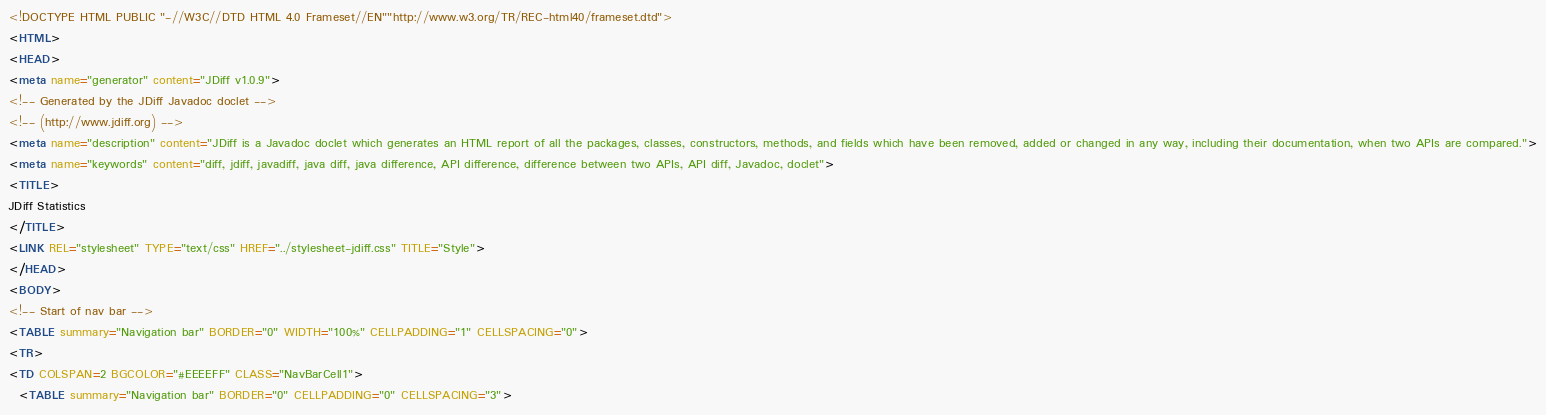<code> <loc_0><loc_0><loc_500><loc_500><_HTML_><!DOCTYPE HTML PUBLIC "-//W3C//DTD HTML 4.0 Frameset//EN""http://www.w3.org/TR/REC-html40/frameset.dtd">
<HTML>
<HEAD>
<meta name="generator" content="JDiff v1.0.9">
<!-- Generated by the JDiff Javadoc doclet -->
<!-- (http://www.jdiff.org) -->
<meta name="description" content="JDiff is a Javadoc doclet which generates an HTML report of all the packages, classes, constructors, methods, and fields which have been removed, added or changed in any way, including their documentation, when two APIs are compared.">
<meta name="keywords" content="diff, jdiff, javadiff, java diff, java difference, API difference, difference between two APIs, API diff, Javadoc, doclet">
<TITLE>
JDiff Statistics
</TITLE>
<LINK REL="stylesheet" TYPE="text/css" HREF="../stylesheet-jdiff.css" TITLE="Style">
</HEAD>
<BODY>
<!-- Start of nav bar -->
<TABLE summary="Navigation bar" BORDER="0" WIDTH="100%" CELLPADDING="1" CELLSPACING="0">
<TR>
<TD COLSPAN=2 BGCOLOR="#EEEEFF" CLASS="NavBarCell1">
  <TABLE summary="Navigation bar" BORDER="0" CELLPADDING="0" CELLSPACING="3"></code> 